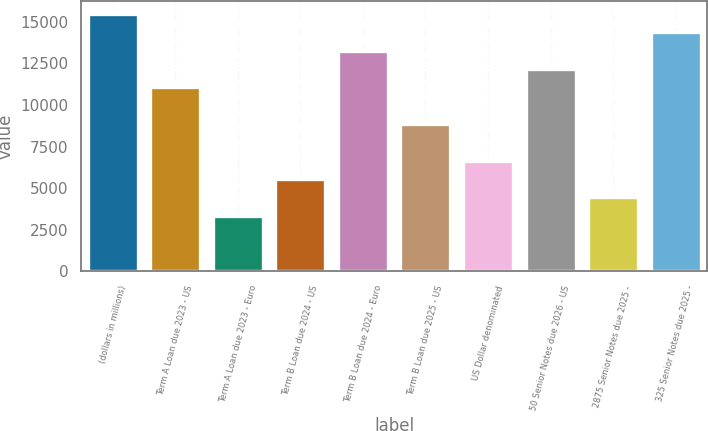Convert chart to OTSL. <chart><loc_0><loc_0><loc_500><loc_500><bar_chart><fcel>(dollars in millions)<fcel>Term A Loan due 2023 - US<fcel>Term A Loan due 2023 - Euro<fcel>Term B Loan due 2024 - US<fcel>Term B Loan due 2024 - Euro<fcel>Term B Loan due 2025 - US<fcel>US Dollar denominated<fcel>50 Senior Notes due 2026 - US<fcel>2875 Senior Notes due 2025 -<fcel>325 Senior Notes due 2025 -<nl><fcel>15458.8<fcel>11056<fcel>3351.1<fcel>5552.5<fcel>13257.4<fcel>8854.6<fcel>6653.2<fcel>12156.7<fcel>4451.8<fcel>14358.1<nl></chart> 